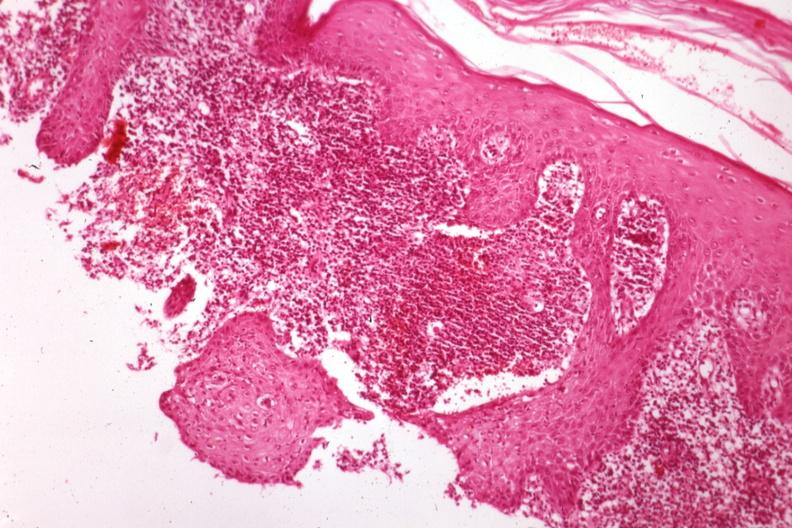s malignant histiocytosis present?
Answer the question using a single word or phrase. No 